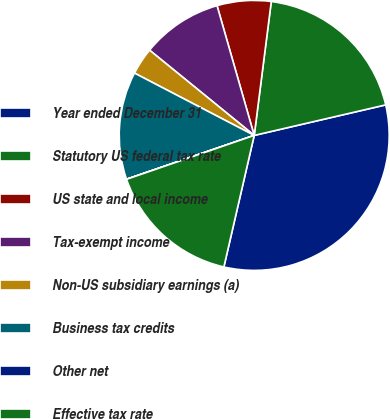Convert chart. <chart><loc_0><loc_0><loc_500><loc_500><pie_chart><fcel>Year ended December 31<fcel>Statutory US federal tax rate<fcel>US state and local income<fcel>Tax-exempt income<fcel>Non-US subsidiary earnings (a)<fcel>Business tax credits<fcel>Other net<fcel>Effective tax rate<nl><fcel>32.24%<fcel>19.35%<fcel>6.46%<fcel>9.68%<fcel>3.24%<fcel>12.9%<fcel>0.01%<fcel>16.12%<nl></chart> 